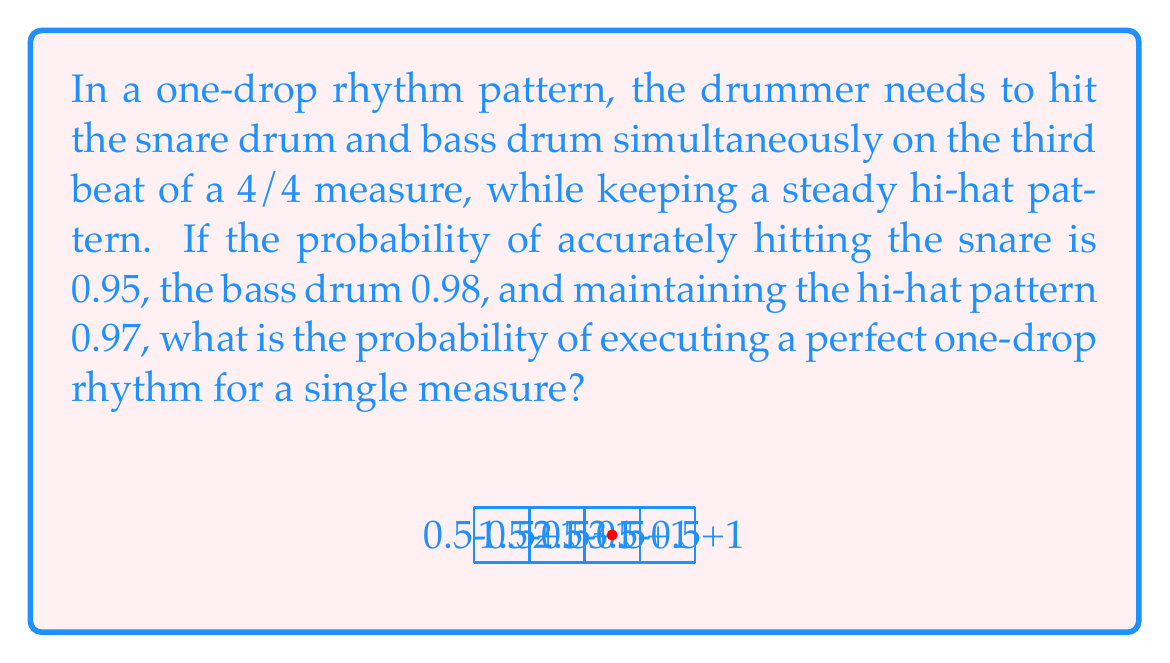Help me with this question. To solve this problem, we need to consider the probability of all events occurring simultaneously. The events are:

1. Hitting the snare drum accurately (probability = 0.95)
2. Hitting the bass drum accurately (probability = 0.98)
3. Maintaining the hi-hat pattern (probability = 0.97)

For a perfect one-drop rhythm, all these events must occur together. In probability theory, when we want all independent events to occur simultaneously, we multiply their individual probabilities.

Let's define the events:
- S: Successfully hitting the snare drum
- B: Successfully hitting the bass drum
- H: Successfully maintaining the hi-hat pattern

The probability of all events occurring together is:

$$P(\text{Perfect One-Drop}) = P(S \cap B \cap H) = P(S) \times P(B) \times P(H)$$

Substituting the given probabilities:

$$P(\text{Perfect One-Drop}) = 0.95 \times 0.98 \times 0.97$$

Calculating:

$$P(\text{Perfect One-Drop}) = 0.90251$$

Therefore, the probability of executing a perfect one-drop rhythm for a single measure is approximately 0.90251 or about 90.25%.
Answer: $0.90251$ 